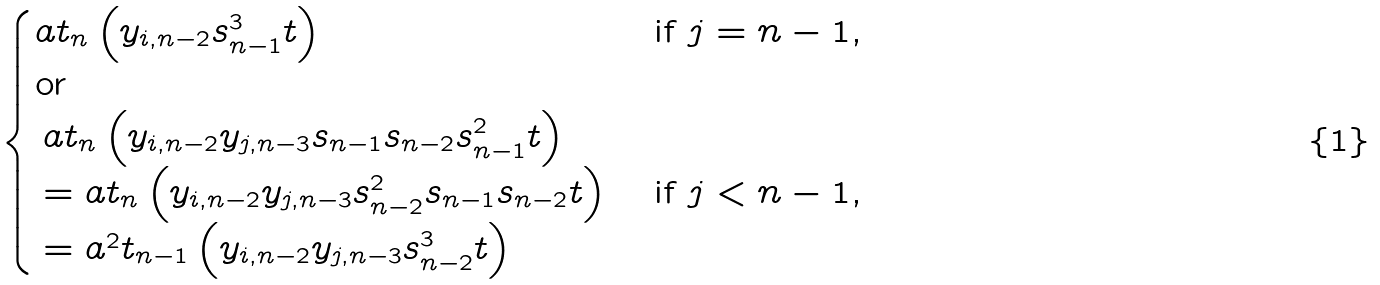<formula> <loc_0><loc_0><loc_500><loc_500>\begin{cases} a t _ { n } \left ( y _ { i , n - 2 } s _ { n - 1 } ^ { 3 } t \right ) & \text {if $j=n-1$,} \\ \text {or} & \\ \begin{array} { l } a t _ { n } \left ( y _ { i , n - 2 } y _ { j , n - 3 } s _ { n - 1 } s _ { n - 2 } s _ { n - 1 } ^ { 2 } t \right ) \\ = a t _ { n } \left ( y _ { i , n - 2 } y _ { j , n - 3 } s _ { n - 2 } ^ { 2 } s _ { n - 1 } s _ { n - 2 } t \right ) \\ = a ^ { 2 } t _ { n - 1 } \left ( y _ { i , n - 2 } y _ { j , n - 3 } s _ { n - 2 } ^ { 3 } t \right ) \end{array} & \text {if $j<n-1$,} \end{cases}</formula> 